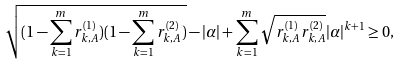Convert formula to latex. <formula><loc_0><loc_0><loc_500><loc_500>\sqrt { ( 1 - \sum _ { k = 1 } ^ { m } r _ { k , A } ^ { ( 1 ) } ) ( 1 - \sum _ { k = 1 } ^ { m } r _ { k , A } ^ { ( 2 ) } ) } - | \alpha | + \sum _ { k = 1 } ^ { m } \sqrt { r _ { k , A } ^ { ( 1 ) } r _ { k , A } ^ { ( 2 ) } } | \alpha | ^ { k + 1 } \geq 0 ,</formula> 